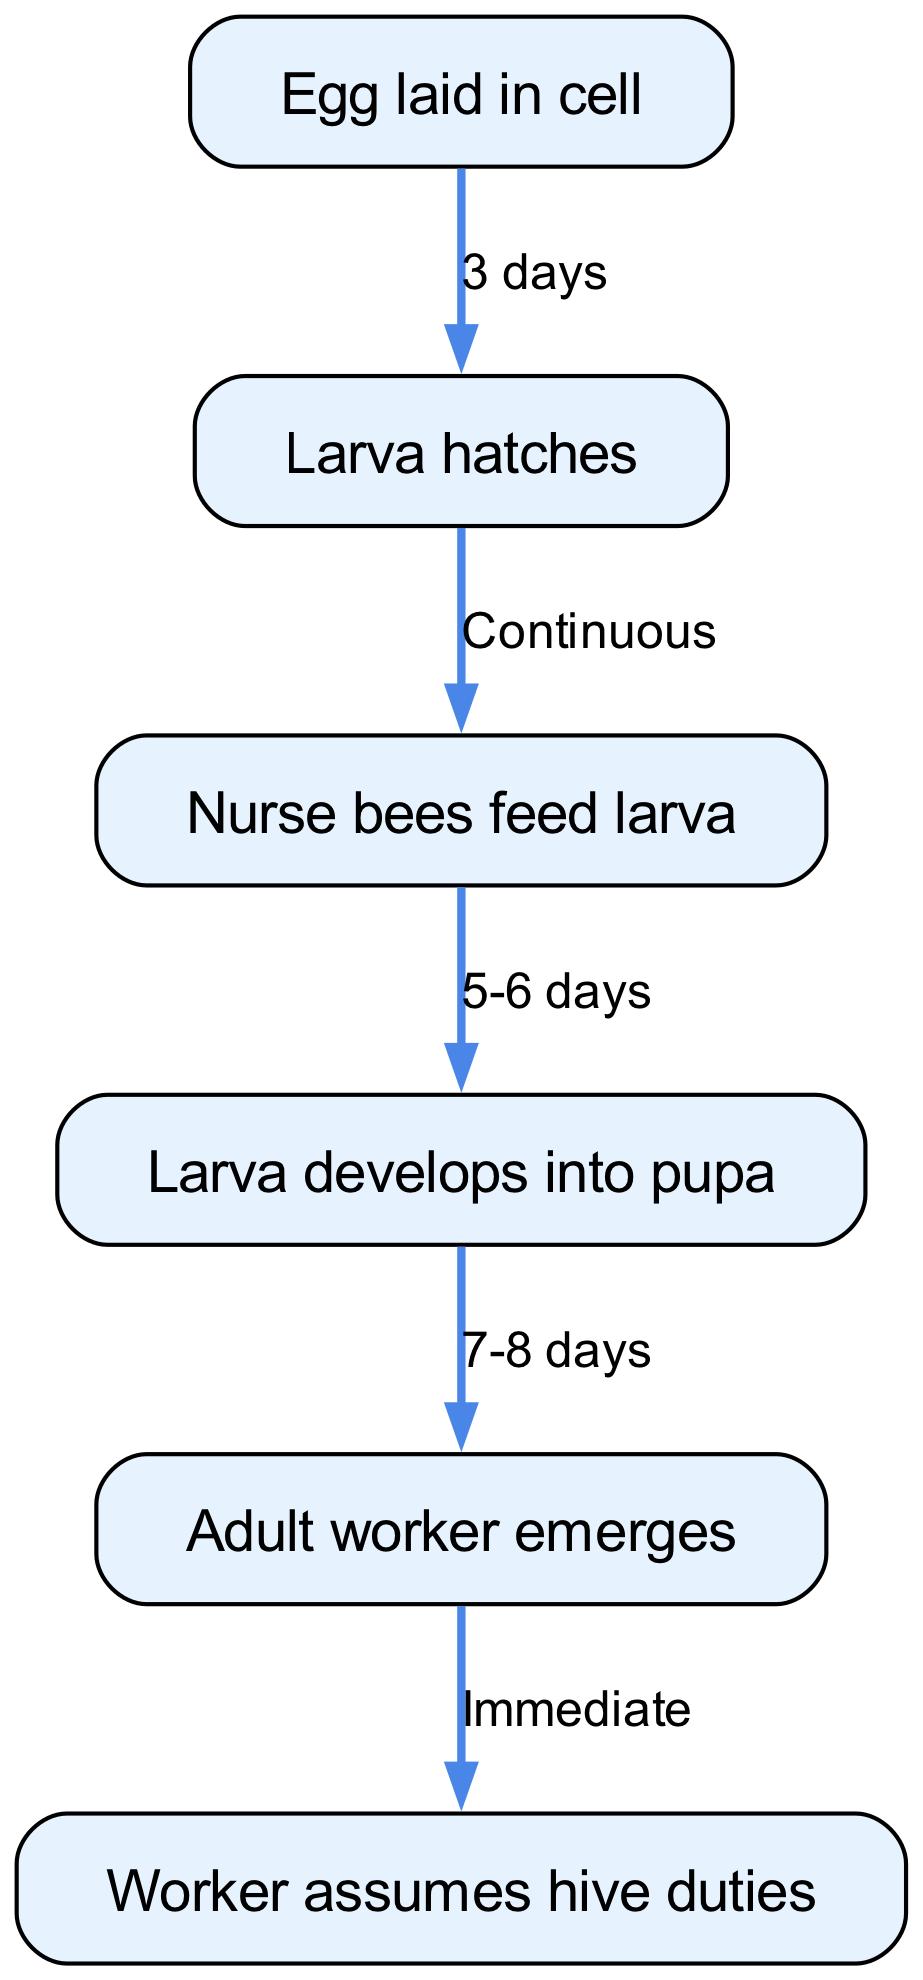What is the first stage in the honey bee life cycle? The first stage in the life cycle is represented by the node labeled "Egg laid in cell." This is the starting point of the life cycle before any development occurs.
Answer: Egg laid in cell How many days does it take for the larva to hatch? According to the edge connected to the "Egg" node, it takes 3 days for the egg to hatch into a larva. The diagram explicitly shows this time duration.
Answer: 3 days What follows the larva hatching? The sequence shown in the diagram indicates that after the larva hatches, the next stage is indicated by the node "Nurse bees feed larva." This is directly connected to the larva node.
Answer: Nurse bees feed larva How many days does the feeding stage last before the larva develops into a pupa? The edge leading from the "Nurse bees feed larva" node to the "Larva develops into pupa" node indicates that this feeding process lasts for 5-6 days. The diagram specifies this duration.
Answer: 5-6 days What is the final stage before the adult bee emerges? In the flow chart, after the larva has transformed into a pupa, the next stage is the "Larva develops into pupa." This is the last stage before becoming an adult worker.
Answer: Larva develops into pupa What happens immediately after the adult bee emerges? The diagram indicates that right after the "Adult worker emerges" node, the bee takes on tasks, as shown in the subsequent node. This relationship indicates the immediate action taken by the adult bee.
Answer: Worker assumes hive duties How many nodes are there in total in the diagram? By counting the nodes listed in the diagram's data ("egg," "larva," "feeding," "pupa," "adult," "roles"), it totals to six nodes. This includes every stage and action in the life cycle.
Answer: 6 Which node represents the stage where the honey bee becomes a pupa? The edge connects the "Larva" node to the "Pupa" node. This indicates that the stage represented by the "Pupa" node is where the larva transforms into a pupa.
Answer: Pupa What is the average duration from pupa to adult? From the "Pupa" node to the "Adult" node, the diagram shows a duration of 7-8 days. This is the time it takes for a larva to transition into an adult worker.
Answer: 7-8 days 